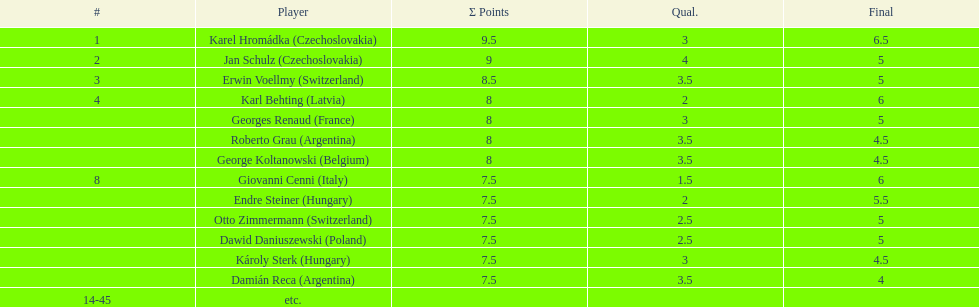Was the total score of the two hungarian competitors more or less than that of the two argentine competitors? Less. 